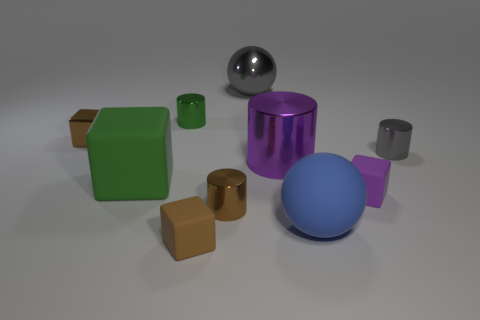Are there any cylinders of the same size as the gray metal sphere?
Provide a short and direct response. Yes. There is a small thing in front of the tiny brown shiny object that is in front of the purple shiny cylinder; are there any small gray shiny things in front of it?
Ensure brevity in your answer.  No. There is a large cylinder; is its color the same as the cylinder in front of the green rubber cube?
Offer a very short reply. No. There is a small cylinder that is in front of the small matte block that is to the right of the large shiny object that is behind the small gray cylinder; what is its material?
Your answer should be very brief. Metal. What is the shape of the green object in front of the small gray cylinder?
Offer a terse response. Cube. What size is the purple object that is the same material as the big blue ball?
Provide a short and direct response. Small. How many gray things have the same shape as the big blue rubber object?
Your answer should be compact. 1. There is a large metal object that is behind the green cylinder; is it the same color as the big matte block?
Your answer should be very brief. No. How many small metal blocks are behind the cylinder that is on the left side of the small metal cylinder in front of the purple rubber block?
Give a very brief answer. 0. What number of large things are in front of the small green cylinder and behind the purple rubber block?
Give a very brief answer. 2. 